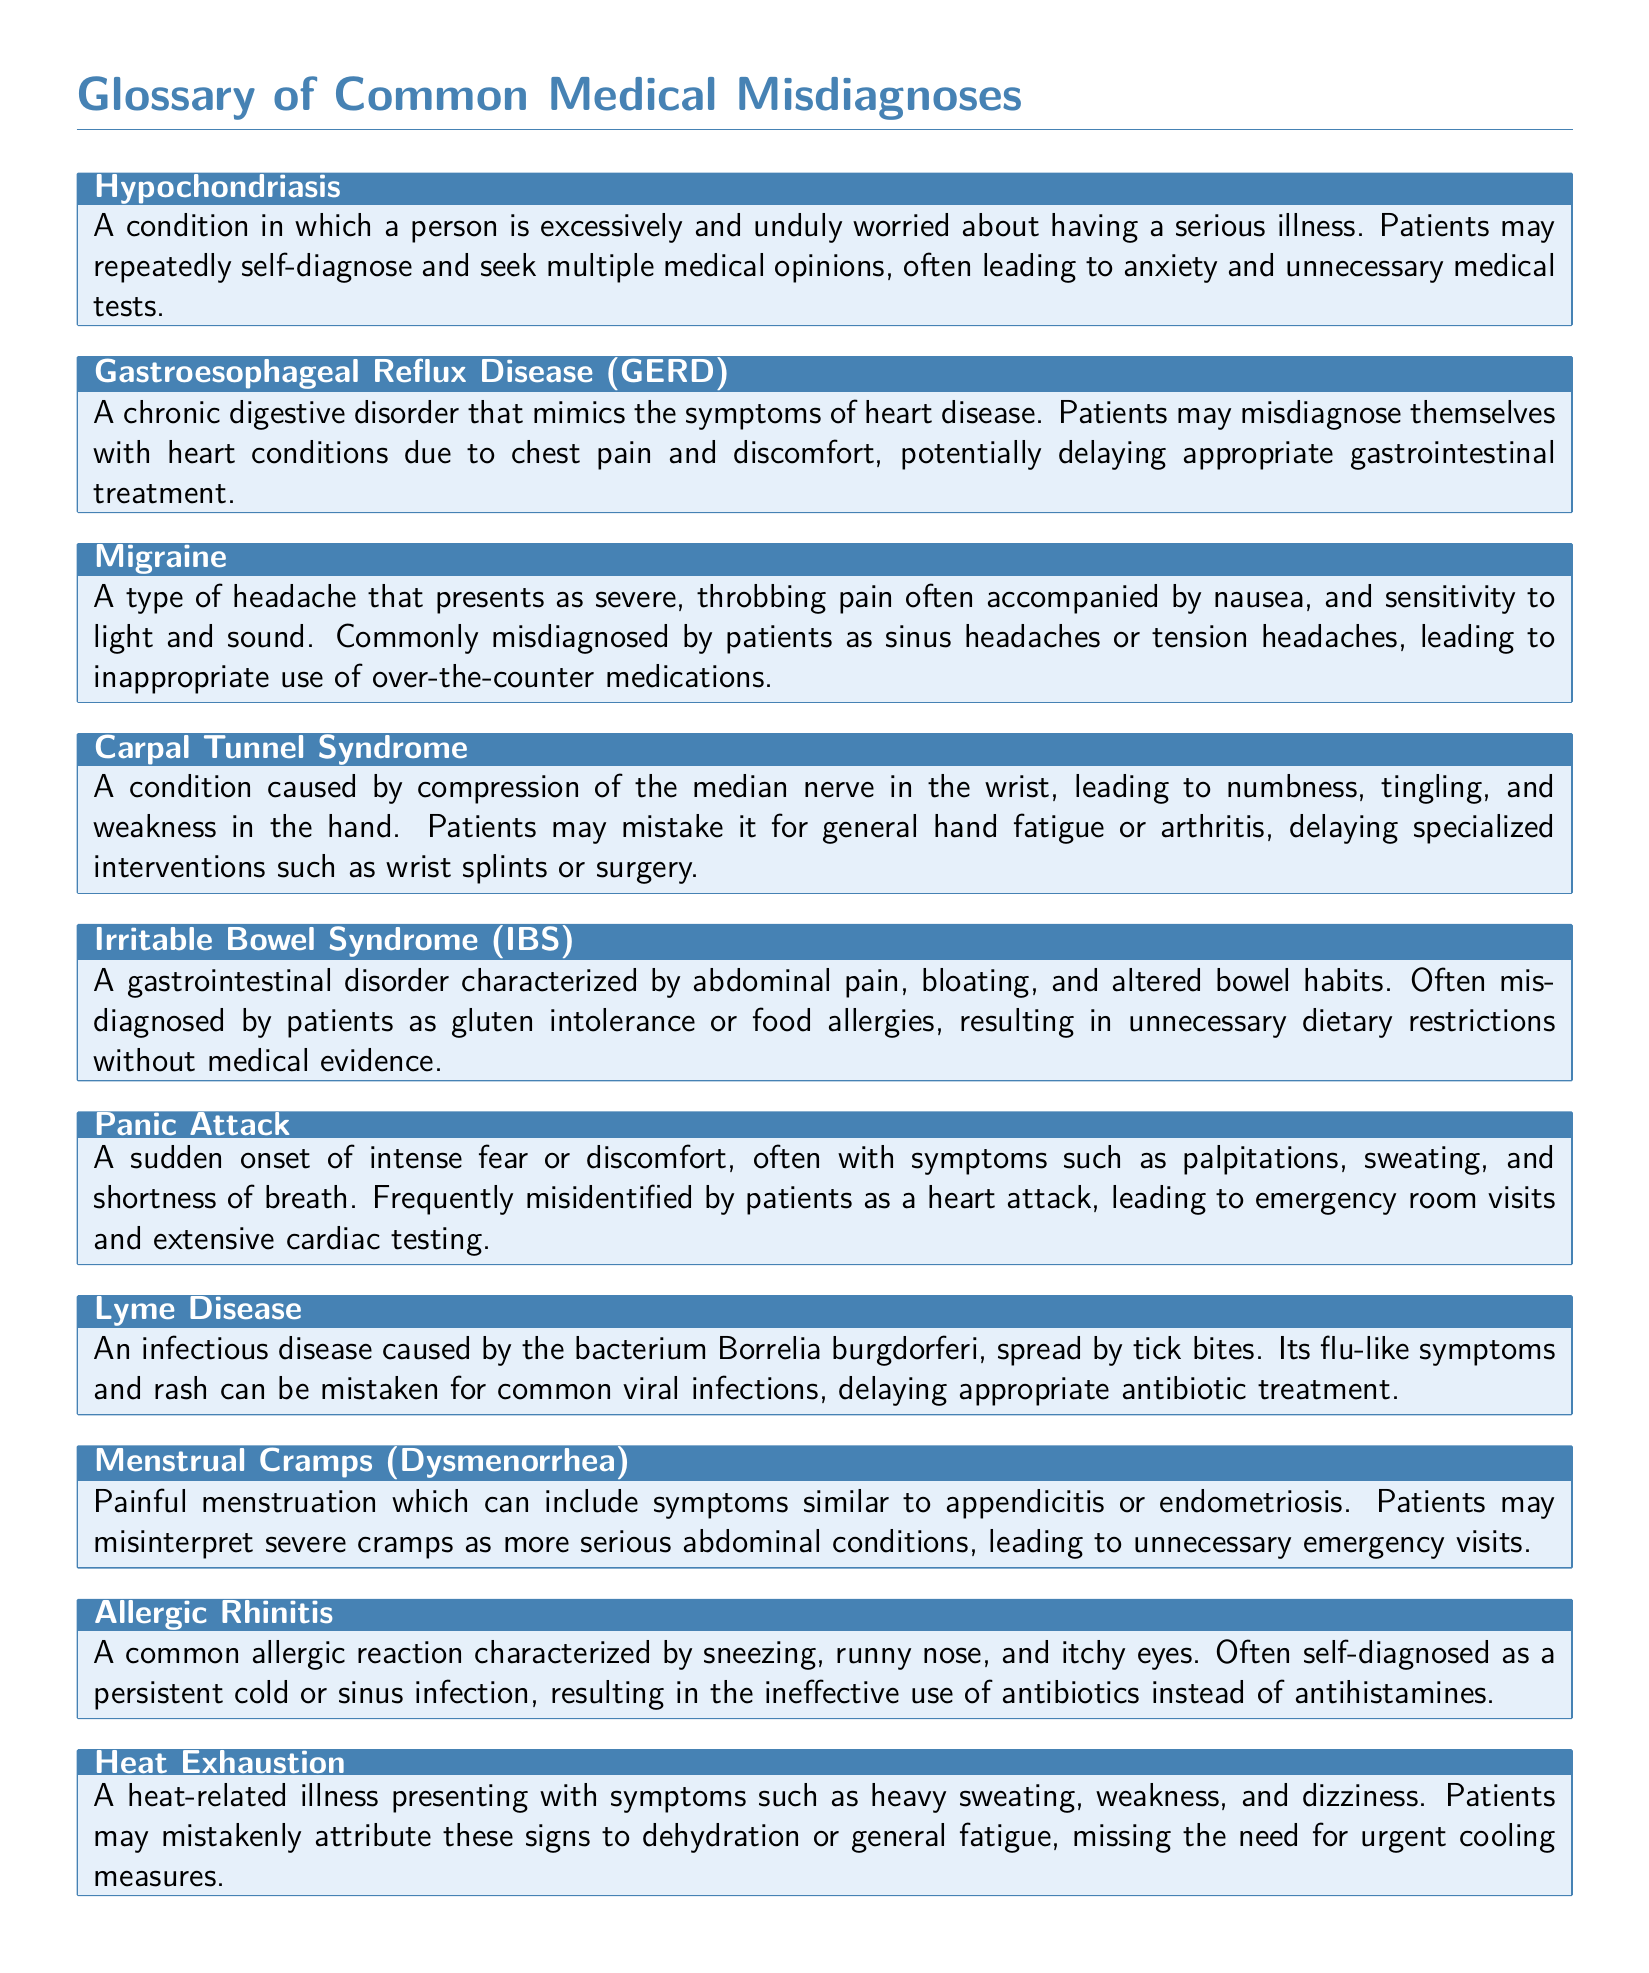What is Hypochondriasis? Hypochondriasis is defined in the glossary as a condition in which a person is excessively and unduly worried about having a serious illness.
Answer: A condition in which a person is excessively and unduly worried about having a serious illness What condition mimics heart disease symptoms due to chest pain? The glossary states that Gastroesophageal Reflux Disease (GERD) can present symptoms that simulate heart disease, leading to misdiagnosis.
Answer: Gastroesophageal Reflux Disease (GERD) What is a common misconception about migraines? The glossary lists that patients often misdiagnose migraines as sinus headaches or tension headaches, leading to inappropriate medication use.
Answer: Sinus headaches or tension headaches Which syndrome is caused by compression of the median nerve? Carpal Tunnel Syndrome is identified in the glossary as being caused by compression of the median nerve in the wrist.
Answer: Carpal Tunnel Syndrome What psychological event is commonly misidentified as a heart attack? The glossary indicates that Panic Attack is frequently misidentified by patients as a heart attack, resulting in unnecessary emergency visits.
Answer: Panic Attack What infection can be misunderstood as a viral infection? Lyme Disease is mentioned in the glossary and can have flu-like symptoms that are mistaken for common viral infections.
Answer: Lyme Disease What allergic reaction is often self-diagnosed as a cold? The glossary states that Allergic Rhinitis is often mistaken by patients for a persistent cold or sinus infection.
Answer: Allergic Rhinitis What condition can lead to unnecessary emergency visits due to severe cramps? Menstrual Cramps (Dysmenorrhea) can be misinterpreted by patients as more serious abdominal conditions, leading to unnecessary emergency visits.
Answer: Menstrual Cramps (Dysmenorrhea) What is the primary symptom of Heat Exhaustion? The glossary notes that Heat Exhaustion presents with heavy sweating, weakness, and dizziness among its primary symptoms.
Answer: Heavy sweating, weakness, and dizziness 